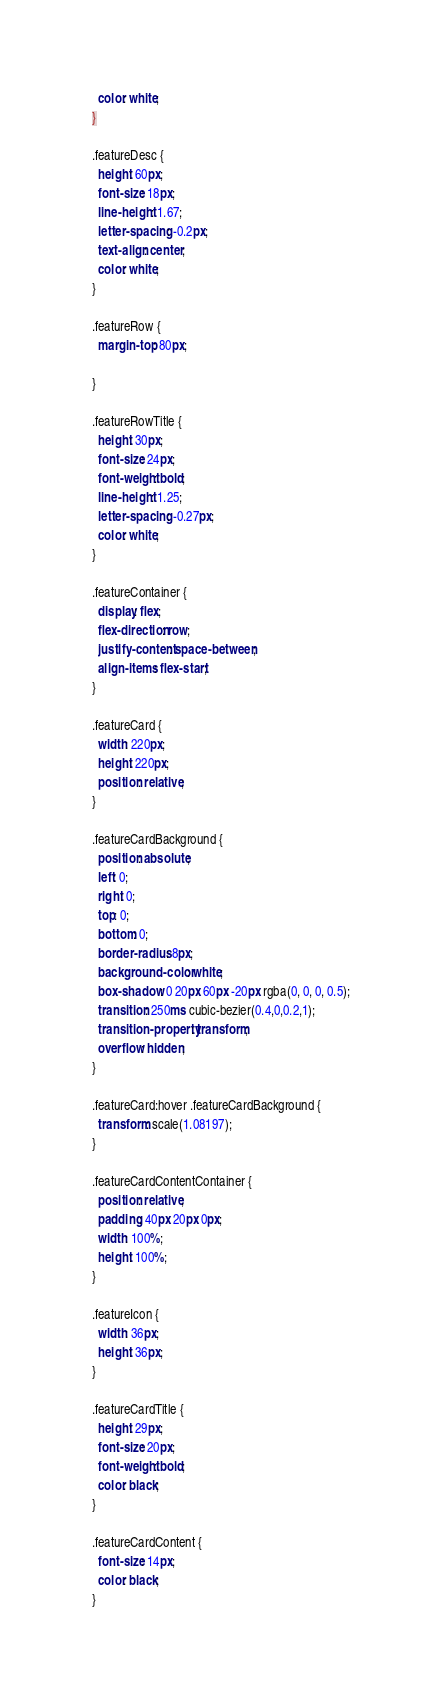<code> <loc_0><loc_0><loc_500><loc_500><_CSS_>  color: white;
}

.featureDesc {
  height: 60px;
  font-size: 18px;
  line-height: 1.67;
  letter-spacing: -0.2px;
  text-align: center;
  color: white;
}

.featureRow {
  margin-top: 80px;

}

.featureRowTitle {
  height: 30px;
  font-size: 24px;
  font-weight: bold;
  line-height: 1.25;
  letter-spacing: -0.27px;
  color: white;
}

.featureContainer {
  display: flex;
  flex-direction: row;
  justify-content: space-between;
  align-items: flex-start;
}

.featureCard {
  width: 220px;
  height: 220px;
  position: relative;
}

.featureCardBackground {
  position: absolute;
  left: 0;
  right: 0;
  top: 0;
  bottom: 0;
  border-radius: 8px;
  background-color: white;
  box-shadow: 0 20px 60px -20px rgba(0, 0, 0, 0.5);
  transition: 250ms cubic-bezier(0.4,0,0.2,1);
  transition-property: transform;
  overflow: hidden;
}

.featureCard:hover .featureCardBackground {
  transform: scale(1.08197);
}

.featureCardContentContainer {
  position: relative;
  padding: 40px 20px 0px;
  width: 100%;
  height: 100%;
}

.featureIcon {
  width: 36px;
  height: 36px;
}

.featureCardTitle {
  height: 29px;
  font-size: 20px;
  font-weight: bold;
  color: black;
}

.featureCardContent {
  font-size: 14px;
  color: black;
}
</code> 